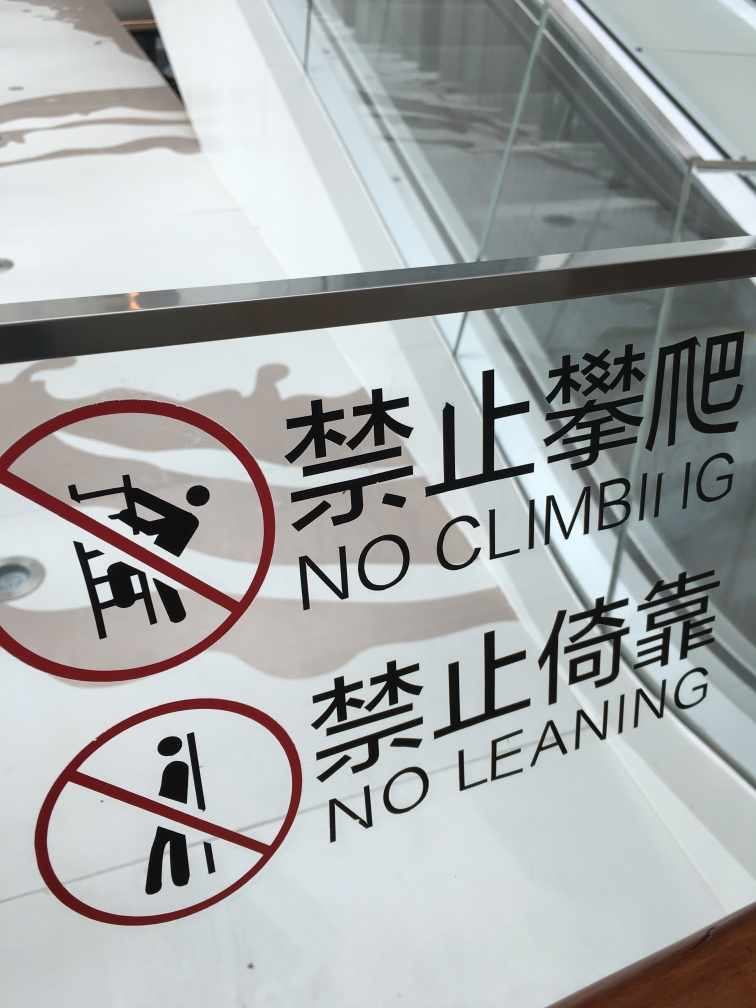Are the colors relatively monotone?
A. Yes
B. No
Answer with the option's letter from the given choices directly.
 A. 